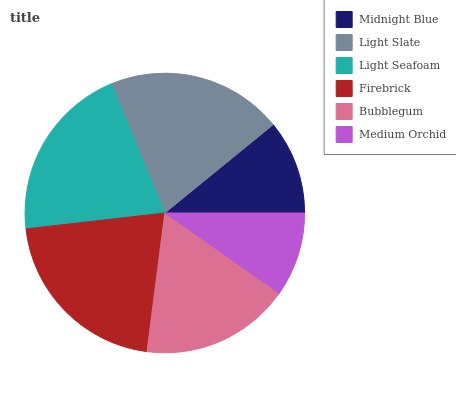Is Medium Orchid the minimum?
Answer yes or no. Yes. Is Firebrick the maximum?
Answer yes or no. Yes. Is Light Slate the minimum?
Answer yes or no. No. Is Light Slate the maximum?
Answer yes or no. No. Is Light Slate greater than Midnight Blue?
Answer yes or no. Yes. Is Midnight Blue less than Light Slate?
Answer yes or no. Yes. Is Midnight Blue greater than Light Slate?
Answer yes or no. No. Is Light Slate less than Midnight Blue?
Answer yes or no. No. Is Light Slate the high median?
Answer yes or no. Yes. Is Bubblegum the low median?
Answer yes or no. Yes. Is Light Seafoam the high median?
Answer yes or no. No. Is Firebrick the low median?
Answer yes or no. No. 